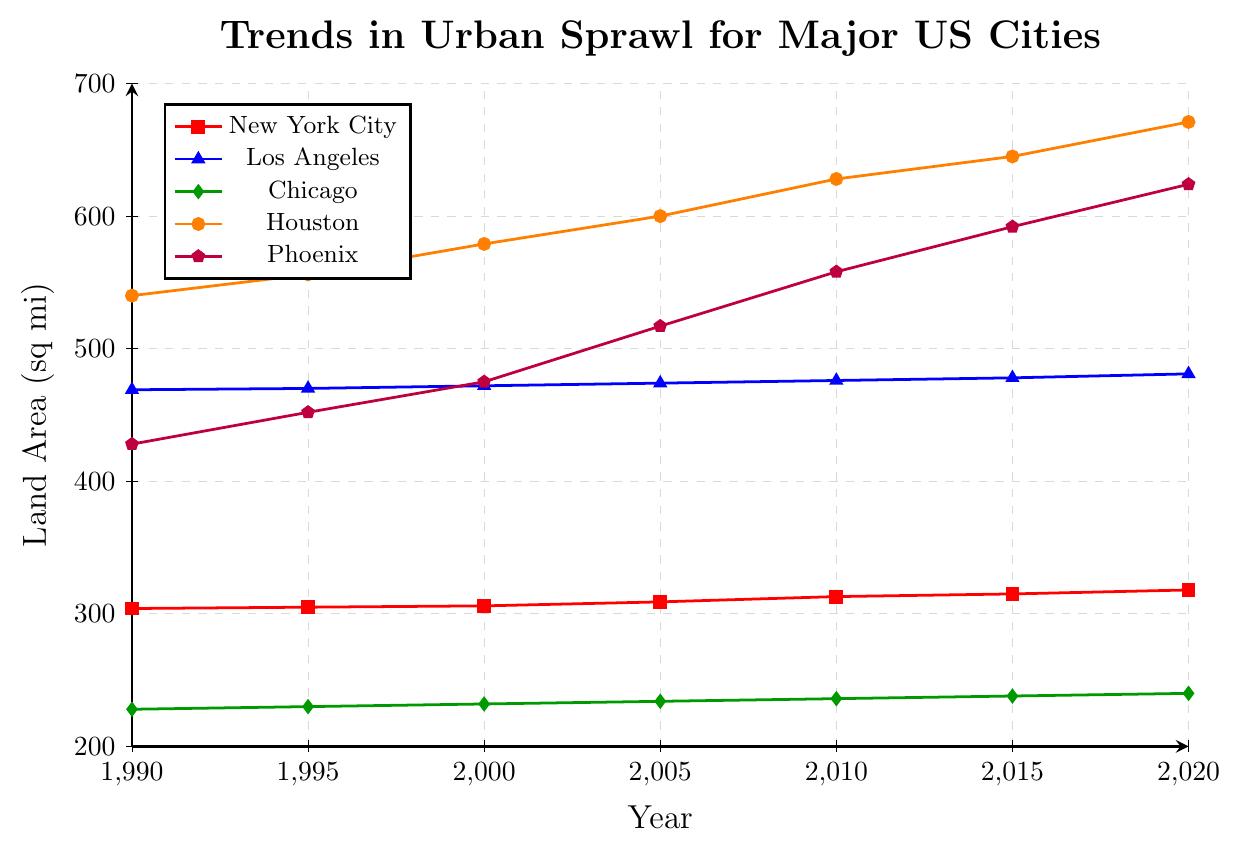What is the approximate increase in land area for Houston from 1990 to 2020? To find the increase, subtract the land area in 1990 from the land area in 2020 for Houston. So, 671 - 540 = 131
Answer: 131 Which city had the highest land area in 2010? Compare the land areas of the cities in 2010. Houston had the highest land area with 628 sq mi.
Answer: Houston What is the average land area of New York City over the 30 years? Add up the land areas of New York City for each year: 304 + 305 + 306 + 309 + 313 + 315 + 318 = 2170; then divide by the number of years, which is 7: 2170 / 7 = 310
Answer: 310 Which city shows the steepest increase in land area between 1990 and 2020? Calculate the increase for each city and compare. Houston increased from 540 to 671 (131), Phoenix from 428 to 624 (196), Los Angeles from 469 to 481 (12), Chicago from 228 to 240 (12), and New York City from 304 to 318 (14). Phoenix had the steepest increase of 196 sq mi.
Answer: Phoenix What is the difference in land area between Los Angeles and Chicago in 2020? Subtract the land area of Chicago from Los Angeles in 2020: 481 - 240 = 241
Answer: 241 Which city’s land area had the least growth over the 30 years? Compare the growth of each city’s land area: New York City (14), Los Angeles (12), Chicago (12), Houston (131), Phoenix (196). Los Angeles and Chicago had the least growth, both increasing by 12 sq mi.
Answer: Los Angeles and Chicago How does the trend in land area for Phoenix compare to that of New York City from 1990 to 2020? Phoenix shows a significant increase from 428 to 624, whereas New York City shows a minimal increase from 304 to 318. Phoenix's trend shows a much steeper growth than New York City.
Answer: Phoenix's increase is much steeper If the trend continues, which city is likely to surpass 500 sq mi in land area next? Based on the trends, Phoenix is the closest to 500 sq mi and its historical growth rate suggests it will surpass 500 sq mi next.
Answer: Phoenix 